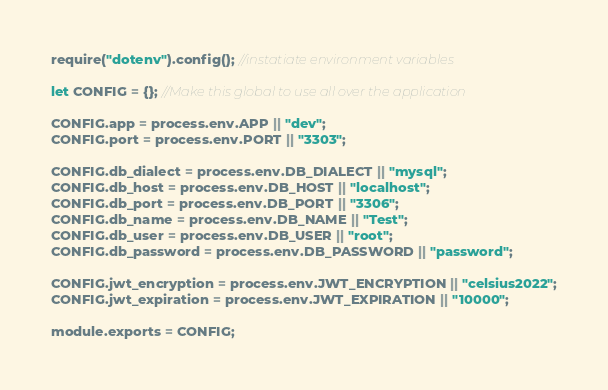Convert code to text. <code><loc_0><loc_0><loc_500><loc_500><_JavaScript_>require("dotenv").config(); //instatiate environment variables

let CONFIG = {}; //Make this global to use all over the application

CONFIG.app = process.env.APP || "dev";
CONFIG.port = process.env.PORT || "3303";

CONFIG.db_dialect = process.env.DB_DIALECT || "mysql";
CONFIG.db_host = process.env.DB_HOST || "localhost";
CONFIG.db_port = process.env.DB_PORT || "3306";
CONFIG.db_name = process.env.DB_NAME || "Test";
CONFIG.db_user = process.env.DB_USER || "root";
CONFIG.db_password = process.env.DB_PASSWORD || "password";

CONFIG.jwt_encryption = process.env.JWT_ENCRYPTION || "celsius2022";
CONFIG.jwt_expiration = process.env.JWT_EXPIRATION || "10000";

module.exports = CONFIG;
</code> 